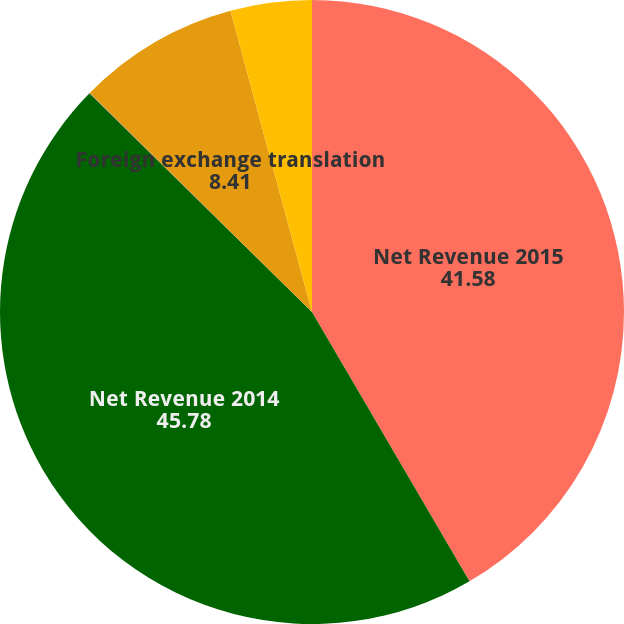Convert chart. <chart><loc_0><loc_0><loc_500><loc_500><pie_chart><fcel>Net Revenue 2015<fcel>Net Revenue 2014<fcel>Volume (a)<fcel>Foreign exchange translation<fcel>Reported growth (d)<nl><fcel>41.58%<fcel>45.78%<fcel>0.02%<fcel>8.41%<fcel>4.21%<nl></chart> 